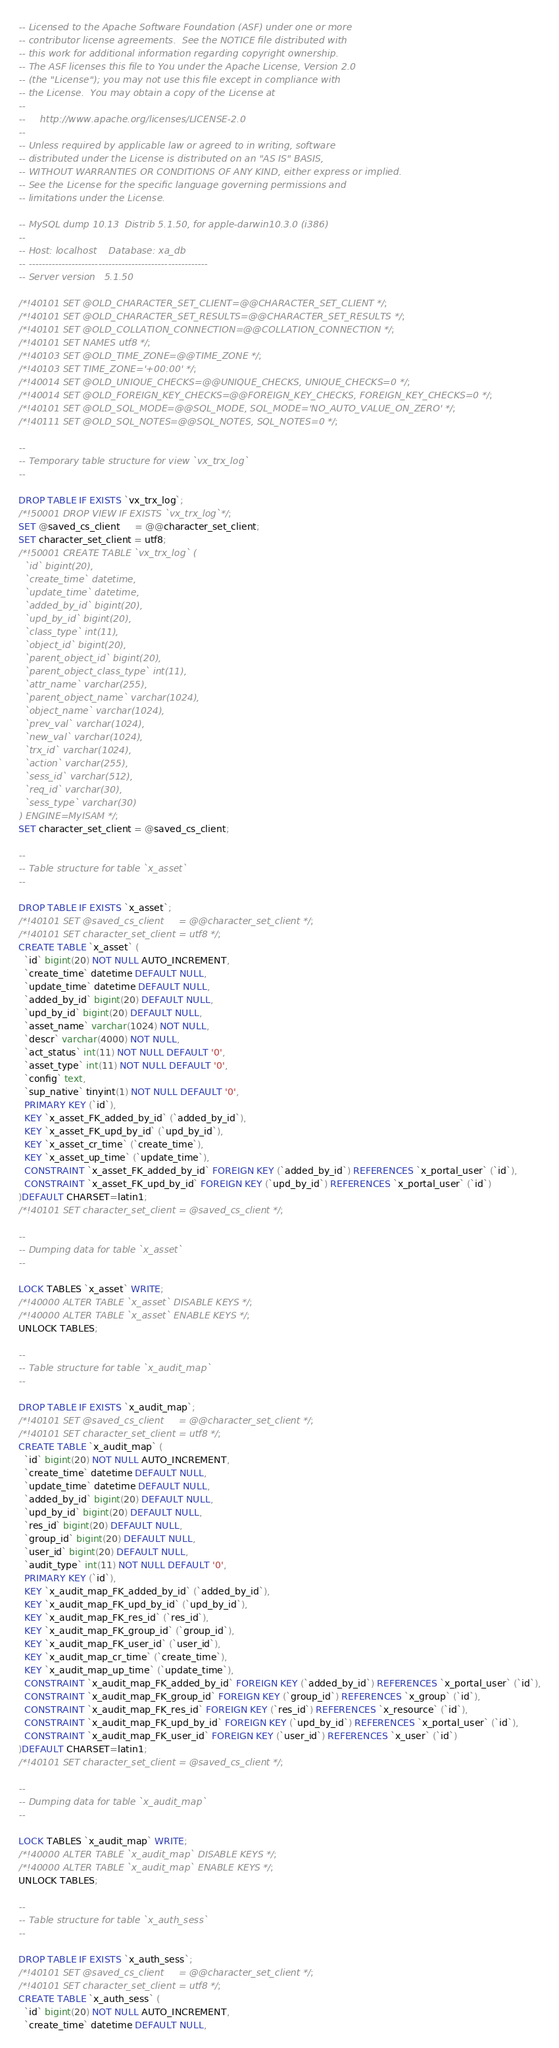<code> <loc_0><loc_0><loc_500><loc_500><_SQL_>-- Licensed to the Apache Software Foundation (ASF) under one or more
-- contributor license agreements.  See the NOTICE file distributed with
-- this work for additional information regarding copyright ownership.
-- The ASF licenses this file to You under the Apache License, Version 2.0
-- (the "License"); you may not use this file except in compliance with
-- the License.  You may obtain a copy of the License at
--
--     http://www.apache.org/licenses/LICENSE-2.0
--
-- Unless required by applicable law or agreed to in writing, software
-- distributed under the License is distributed on an "AS IS" BASIS,
-- WITHOUT WARRANTIES OR CONDITIONS OF ANY KIND, either express or implied.
-- See the License for the specific language governing permissions and
-- limitations under the License.

-- MySQL dump 10.13  Distrib 5.1.50, for apple-darwin10.3.0 (i386)
--
-- Host: localhost    Database: xa_db
-- ------------------------------------------------------
-- Server version	5.1.50

/*!40101 SET @OLD_CHARACTER_SET_CLIENT=@@CHARACTER_SET_CLIENT */;
/*!40101 SET @OLD_CHARACTER_SET_RESULTS=@@CHARACTER_SET_RESULTS */;
/*!40101 SET @OLD_COLLATION_CONNECTION=@@COLLATION_CONNECTION */;
/*!40101 SET NAMES utf8 */;
/*!40103 SET @OLD_TIME_ZONE=@@TIME_ZONE */;
/*!40103 SET TIME_ZONE='+00:00' */;
/*!40014 SET @OLD_UNIQUE_CHECKS=@@UNIQUE_CHECKS, UNIQUE_CHECKS=0 */;
/*!40014 SET @OLD_FOREIGN_KEY_CHECKS=@@FOREIGN_KEY_CHECKS, FOREIGN_KEY_CHECKS=0 */;
/*!40101 SET @OLD_SQL_MODE=@@SQL_MODE, SQL_MODE='NO_AUTO_VALUE_ON_ZERO' */;
/*!40111 SET @OLD_SQL_NOTES=@@SQL_NOTES, SQL_NOTES=0 */;

--
-- Temporary table structure for view `vx_trx_log`
--

DROP TABLE IF EXISTS `vx_trx_log`;
/*!50001 DROP VIEW IF EXISTS `vx_trx_log`*/;
SET @saved_cs_client     = @@character_set_client;
SET character_set_client = utf8;
/*!50001 CREATE TABLE `vx_trx_log` (
  `id` bigint(20),
  `create_time` datetime,
  `update_time` datetime,
  `added_by_id` bigint(20),
  `upd_by_id` bigint(20),
  `class_type` int(11),
  `object_id` bigint(20),
  `parent_object_id` bigint(20),
  `parent_object_class_type` int(11),
  `attr_name` varchar(255),
  `parent_object_name` varchar(1024),
  `object_name` varchar(1024),
  `prev_val` varchar(1024),
  `new_val` varchar(1024),
  `trx_id` varchar(1024),
  `action` varchar(255),
  `sess_id` varchar(512),
  `req_id` varchar(30),
  `sess_type` varchar(30)
) ENGINE=MyISAM */;
SET character_set_client = @saved_cs_client;

--
-- Table structure for table `x_asset`
--

DROP TABLE IF EXISTS `x_asset`;
/*!40101 SET @saved_cs_client     = @@character_set_client */;
/*!40101 SET character_set_client = utf8 */;
CREATE TABLE `x_asset` (
  `id` bigint(20) NOT NULL AUTO_INCREMENT,
  `create_time` datetime DEFAULT NULL,
  `update_time` datetime DEFAULT NULL,
  `added_by_id` bigint(20) DEFAULT NULL,
  `upd_by_id` bigint(20) DEFAULT NULL,
  `asset_name` varchar(1024) NOT NULL,
  `descr` varchar(4000) NOT NULL,
  `act_status` int(11) NOT NULL DEFAULT '0',
  `asset_type` int(11) NOT NULL DEFAULT '0',
  `config` text,
  `sup_native` tinyint(1) NOT NULL DEFAULT '0',
  PRIMARY KEY (`id`),
  KEY `x_asset_FK_added_by_id` (`added_by_id`),
  KEY `x_asset_FK_upd_by_id` (`upd_by_id`),
  KEY `x_asset_cr_time` (`create_time`),
  KEY `x_asset_up_time` (`update_time`),
  CONSTRAINT `x_asset_FK_added_by_id` FOREIGN KEY (`added_by_id`) REFERENCES `x_portal_user` (`id`),
  CONSTRAINT `x_asset_FK_upd_by_id` FOREIGN KEY (`upd_by_id`) REFERENCES `x_portal_user` (`id`)
)DEFAULT CHARSET=latin1;
/*!40101 SET character_set_client = @saved_cs_client */;

--
-- Dumping data for table `x_asset`
--

LOCK TABLES `x_asset` WRITE;
/*!40000 ALTER TABLE `x_asset` DISABLE KEYS */;
/*!40000 ALTER TABLE `x_asset` ENABLE KEYS */;
UNLOCK TABLES;

--
-- Table structure for table `x_audit_map`
--

DROP TABLE IF EXISTS `x_audit_map`;
/*!40101 SET @saved_cs_client     = @@character_set_client */;
/*!40101 SET character_set_client = utf8 */;
CREATE TABLE `x_audit_map` (
  `id` bigint(20) NOT NULL AUTO_INCREMENT,
  `create_time` datetime DEFAULT NULL,
  `update_time` datetime DEFAULT NULL,
  `added_by_id` bigint(20) DEFAULT NULL,
  `upd_by_id` bigint(20) DEFAULT NULL,
  `res_id` bigint(20) DEFAULT NULL,
  `group_id` bigint(20) DEFAULT NULL,
  `user_id` bigint(20) DEFAULT NULL,
  `audit_type` int(11) NOT NULL DEFAULT '0',
  PRIMARY KEY (`id`),
  KEY `x_audit_map_FK_added_by_id` (`added_by_id`),
  KEY `x_audit_map_FK_upd_by_id` (`upd_by_id`),
  KEY `x_audit_map_FK_res_id` (`res_id`),
  KEY `x_audit_map_FK_group_id` (`group_id`),
  KEY `x_audit_map_FK_user_id` (`user_id`),
  KEY `x_audit_map_cr_time` (`create_time`),
  KEY `x_audit_map_up_time` (`update_time`),
  CONSTRAINT `x_audit_map_FK_added_by_id` FOREIGN KEY (`added_by_id`) REFERENCES `x_portal_user` (`id`),
  CONSTRAINT `x_audit_map_FK_group_id` FOREIGN KEY (`group_id`) REFERENCES `x_group` (`id`),
  CONSTRAINT `x_audit_map_FK_res_id` FOREIGN KEY (`res_id`) REFERENCES `x_resource` (`id`),
  CONSTRAINT `x_audit_map_FK_upd_by_id` FOREIGN KEY (`upd_by_id`) REFERENCES `x_portal_user` (`id`),
  CONSTRAINT `x_audit_map_FK_user_id` FOREIGN KEY (`user_id`) REFERENCES `x_user` (`id`)
)DEFAULT CHARSET=latin1;
/*!40101 SET character_set_client = @saved_cs_client */;

--
-- Dumping data for table `x_audit_map`
--

LOCK TABLES `x_audit_map` WRITE;
/*!40000 ALTER TABLE `x_audit_map` DISABLE KEYS */;
/*!40000 ALTER TABLE `x_audit_map` ENABLE KEYS */;
UNLOCK TABLES;

--
-- Table structure for table `x_auth_sess`
--

DROP TABLE IF EXISTS `x_auth_sess`;
/*!40101 SET @saved_cs_client     = @@character_set_client */;
/*!40101 SET character_set_client = utf8 */;
CREATE TABLE `x_auth_sess` (
  `id` bigint(20) NOT NULL AUTO_INCREMENT,
  `create_time` datetime DEFAULT NULL,</code> 